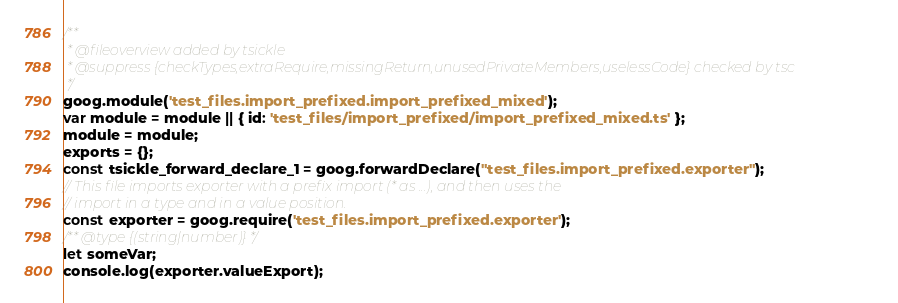Convert code to text. <code><loc_0><loc_0><loc_500><loc_500><_JavaScript_>/**
 * @fileoverview added by tsickle
 * @suppress {checkTypes,extraRequire,missingReturn,unusedPrivateMembers,uselessCode} checked by tsc
 */
goog.module('test_files.import_prefixed.import_prefixed_mixed');
var module = module || { id: 'test_files/import_prefixed/import_prefixed_mixed.ts' };
module = module;
exports = {};
const tsickle_forward_declare_1 = goog.forwardDeclare("test_files.import_prefixed.exporter");
// This file imports exporter with a prefix import (* as ...), and then uses the
// import in a type and in a value position.
const exporter = goog.require('test_files.import_prefixed.exporter');
/** @type {(string|number)} */
let someVar;
console.log(exporter.valueExport);
</code> 